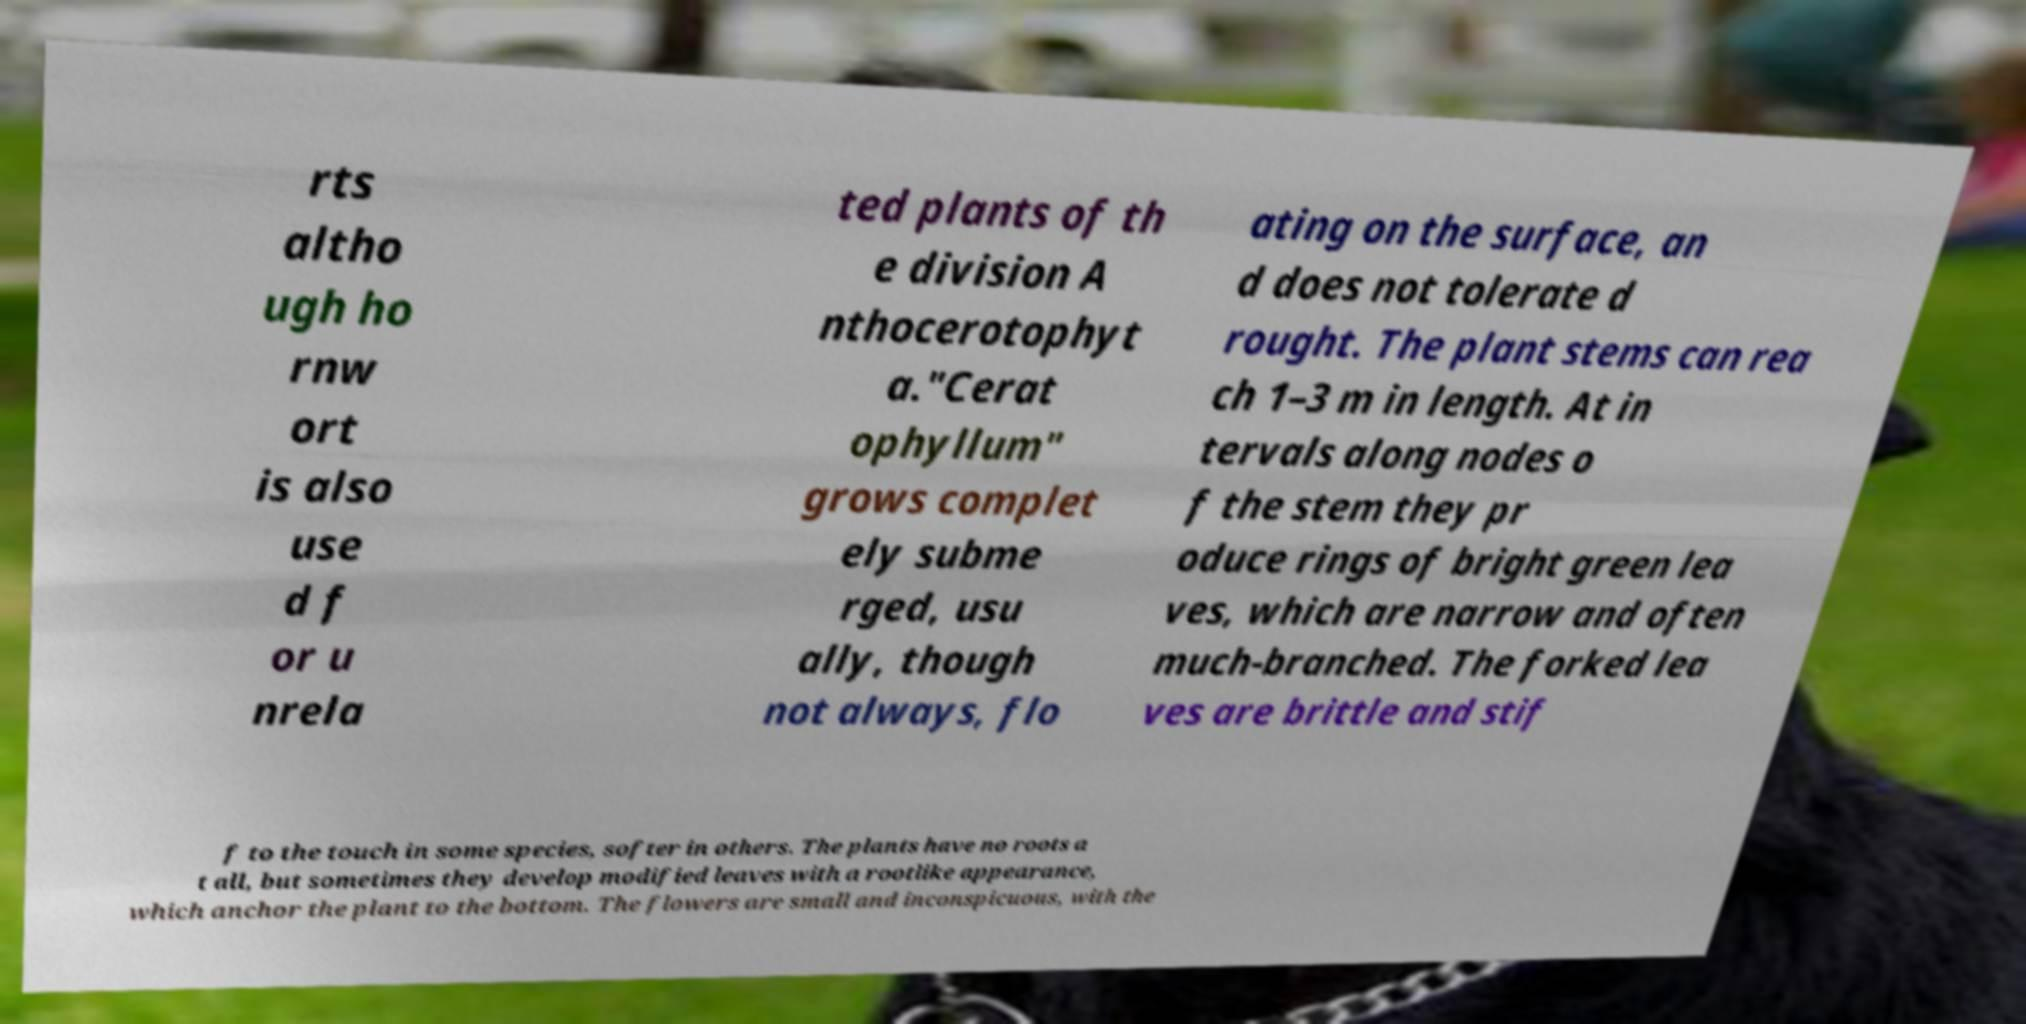Can you accurately transcribe the text from the provided image for me? rts altho ugh ho rnw ort is also use d f or u nrela ted plants of th e division A nthocerotophyt a."Cerat ophyllum" grows complet ely subme rged, usu ally, though not always, flo ating on the surface, an d does not tolerate d rought. The plant stems can rea ch 1–3 m in length. At in tervals along nodes o f the stem they pr oduce rings of bright green lea ves, which are narrow and often much-branched. The forked lea ves are brittle and stif f to the touch in some species, softer in others. The plants have no roots a t all, but sometimes they develop modified leaves with a rootlike appearance, which anchor the plant to the bottom. The flowers are small and inconspicuous, with the 